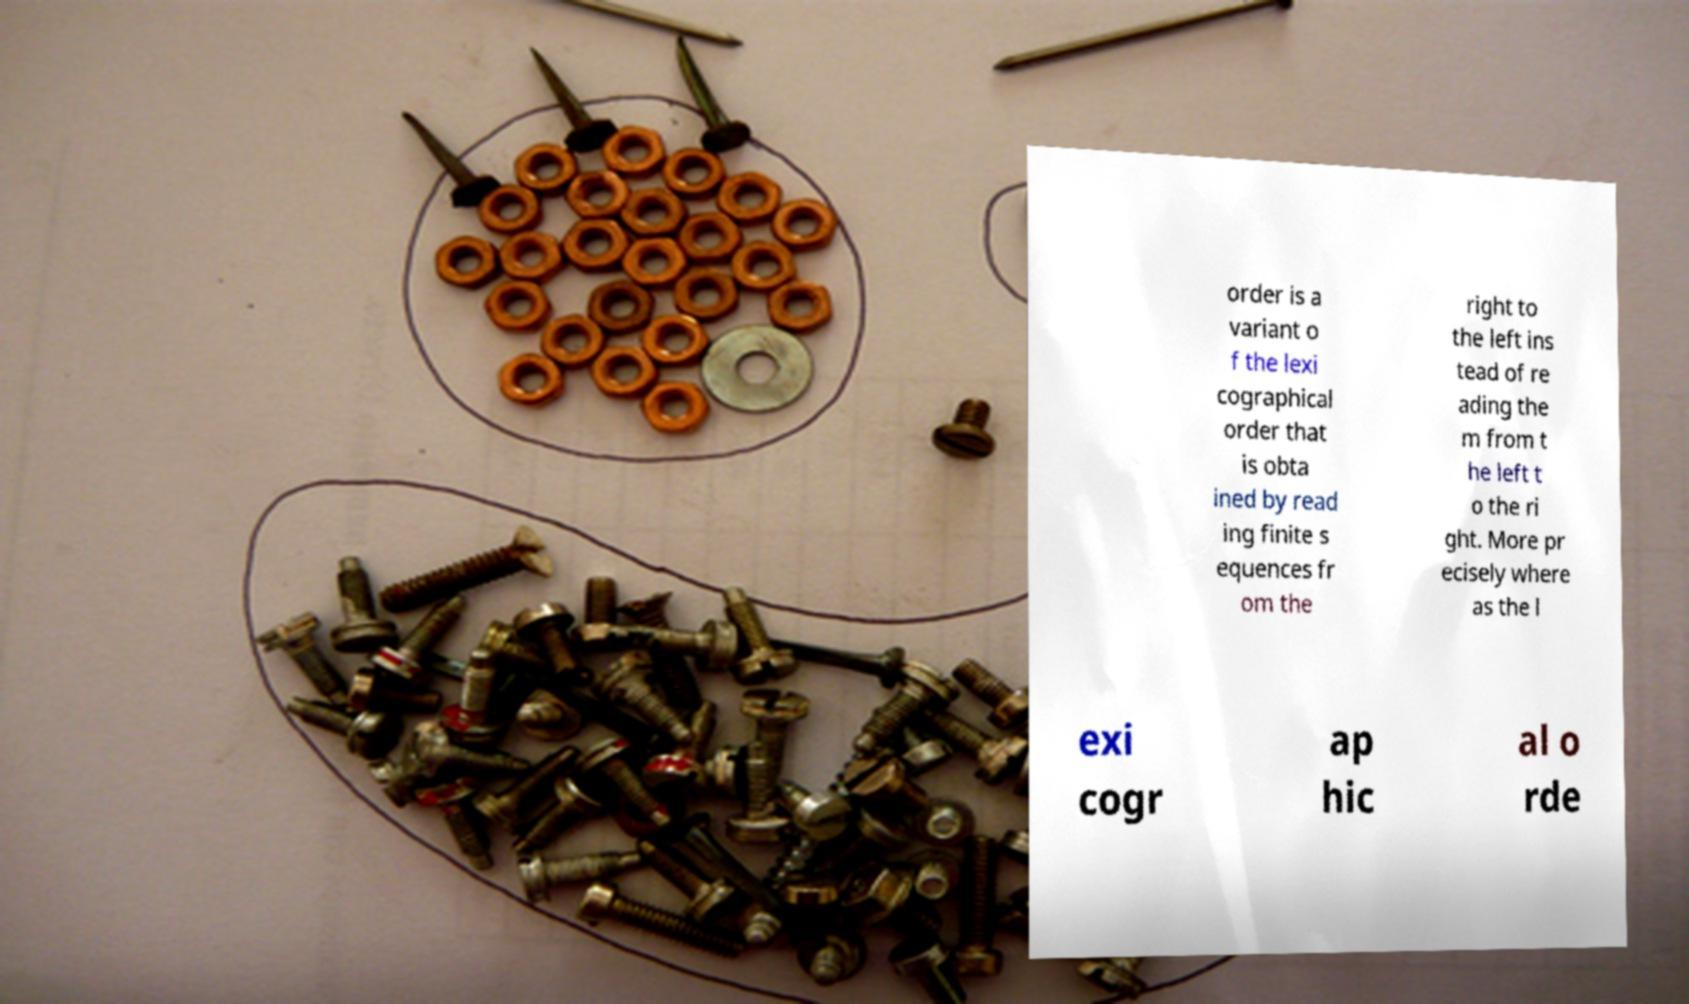Please read and relay the text visible in this image. What does it say? order is a variant o f the lexi cographical order that is obta ined by read ing finite s equences fr om the right to the left ins tead of re ading the m from t he left t o the ri ght. More pr ecisely where as the l exi cogr ap hic al o rde 